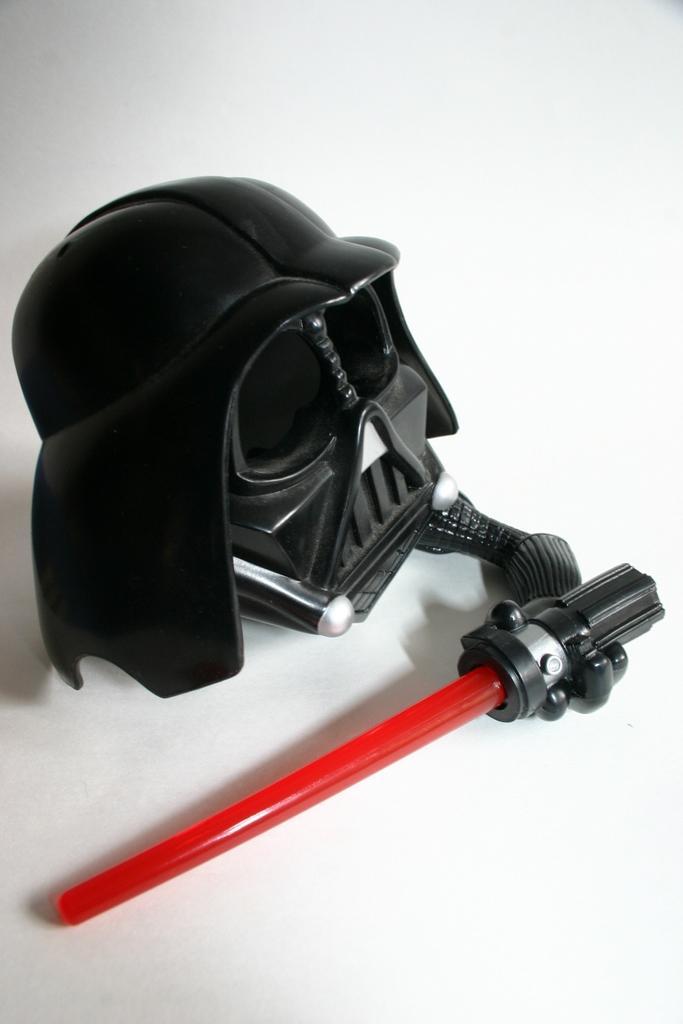Please provide a concise description of this image. In this picture there is a mask and a stick. The surface is white. 